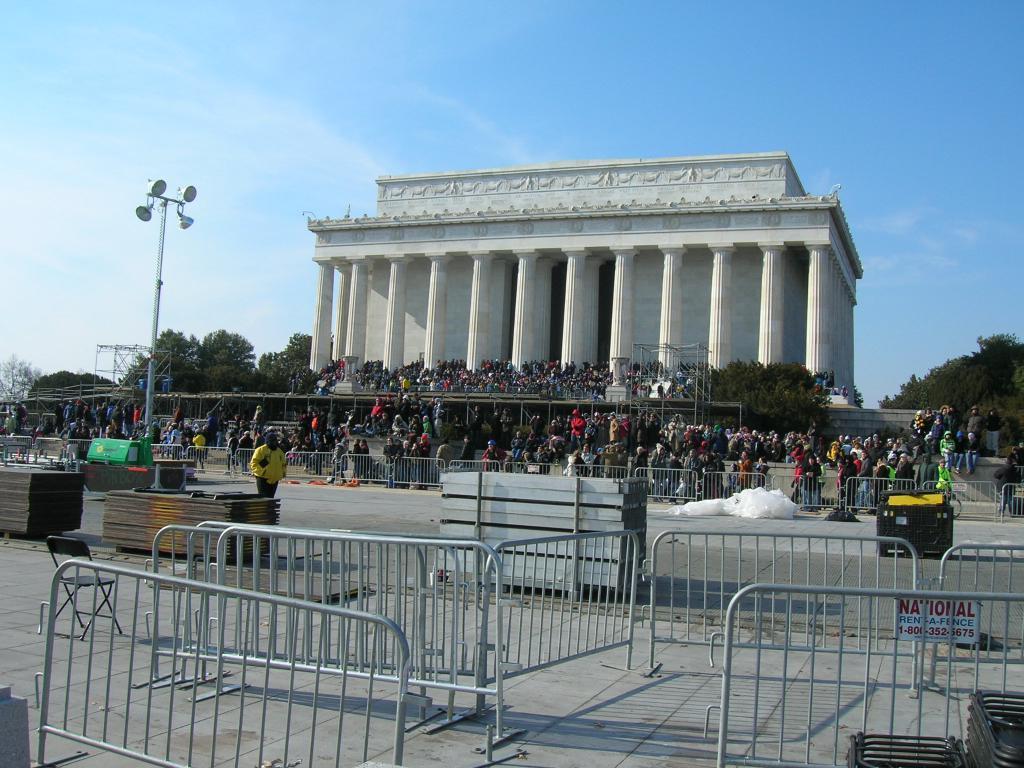How would you summarize this image in a sentence or two? In the foreground of the image we can see iron rods which are used to keep as obstacles. In the middle of the image we can see building, crowd, trees and some lights. On the top, of the image we can see the sky. 